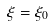Convert formula to latex. <formula><loc_0><loc_0><loc_500><loc_500>\xi = \xi _ { 0 }</formula> 